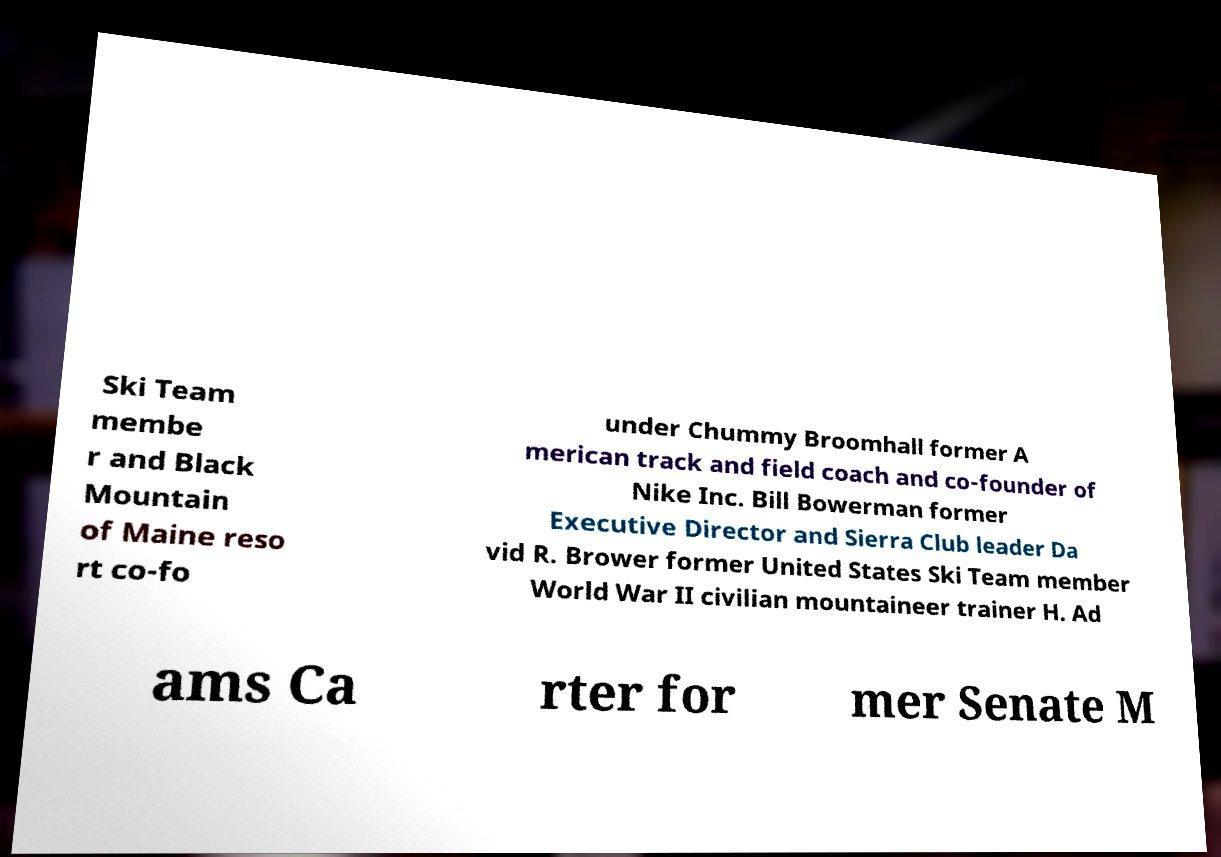There's text embedded in this image that I need extracted. Can you transcribe it verbatim? Ski Team membe r and Black Mountain of Maine reso rt co-fo under Chummy Broomhall former A merican track and field coach and co-founder of Nike Inc. Bill Bowerman former Executive Director and Sierra Club leader Da vid R. Brower former United States Ski Team member World War II civilian mountaineer trainer H. Ad ams Ca rter for mer Senate M 